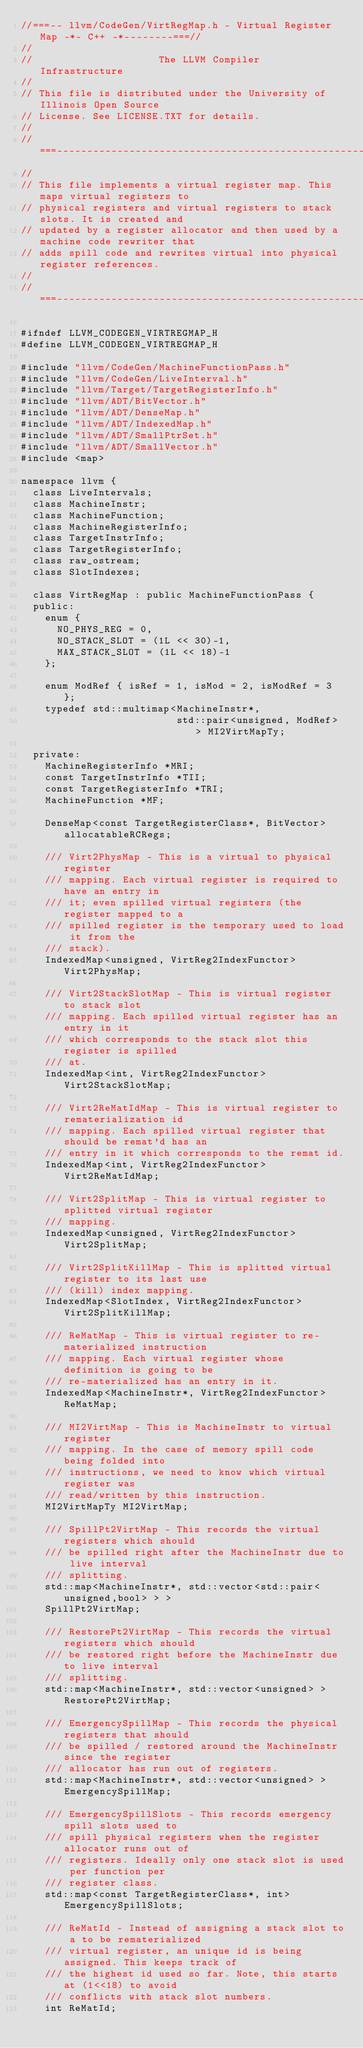<code> <loc_0><loc_0><loc_500><loc_500><_C_>//===-- llvm/CodeGen/VirtRegMap.h - Virtual Register Map -*- C++ -*--------===//
//
//                     The LLVM Compiler Infrastructure
//
// This file is distributed under the University of Illinois Open Source
// License. See LICENSE.TXT for details.
//
//===----------------------------------------------------------------------===//
//
// This file implements a virtual register map. This maps virtual registers to
// physical registers and virtual registers to stack slots. It is created and
// updated by a register allocator and then used by a machine code rewriter that
// adds spill code and rewrites virtual into physical register references.
//
//===----------------------------------------------------------------------===//

#ifndef LLVM_CODEGEN_VIRTREGMAP_H
#define LLVM_CODEGEN_VIRTREGMAP_H

#include "llvm/CodeGen/MachineFunctionPass.h"
#include "llvm/CodeGen/LiveInterval.h"
#include "llvm/Target/TargetRegisterInfo.h"
#include "llvm/ADT/BitVector.h"
#include "llvm/ADT/DenseMap.h"
#include "llvm/ADT/IndexedMap.h"
#include "llvm/ADT/SmallPtrSet.h"
#include "llvm/ADT/SmallVector.h"
#include <map>

namespace llvm {
  class LiveIntervals;
  class MachineInstr;
  class MachineFunction;
  class MachineRegisterInfo;
  class TargetInstrInfo;
  class TargetRegisterInfo;
  class raw_ostream;
  class SlotIndexes;

  class VirtRegMap : public MachineFunctionPass {
  public:
    enum {
      NO_PHYS_REG = 0,
      NO_STACK_SLOT = (1L << 30)-1,
      MAX_STACK_SLOT = (1L << 18)-1
    };

    enum ModRef { isRef = 1, isMod = 2, isModRef = 3 };
    typedef std::multimap<MachineInstr*,
                          std::pair<unsigned, ModRef> > MI2VirtMapTy;

  private:
    MachineRegisterInfo *MRI;
    const TargetInstrInfo *TII;
    const TargetRegisterInfo *TRI;
    MachineFunction *MF;

    DenseMap<const TargetRegisterClass*, BitVector> allocatableRCRegs;

    /// Virt2PhysMap - This is a virtual to physical register
    /// mapping. Each virtual register is required to have an entry in
    /// it; even spilled virtual registers (the register mapped to a
    /// spilled register is the temporary used to load it from the
    /// stack).
    IndexedMap<unsigned, VirtReg2IndexFunctor> Virt2PhysMap;

    /// Virt2StackSlotMap - This is virtual register to stack slot
    /// mapping. Each spilled virtual register has an entry in it
    /// which corresponds to the stack slot this register is spilled
    /// at.
    IndexedMap<int, VirtReg2IndexFunctor> Virt2StackSlotMap;

    /// Virt2ReMatIdMap - This is virtual register to rematerialization id
    /// mapping. Each spilled virtual register that should be remat'd has an
    /// entry in it which corresponds to the remat id.
    IndexedMap<int, VirtReg2IndexFunctor> Virt2ReMatIdMap;

    /// Virt2SplitMap - This is virtual register to splitted virtual register
    /// mapping.
    IndexedMap<unsigned, VirtReg2IndexFunctor> Virt2SplitMap;

    /// Virt2SplitKillMap - This is splitted virtual register to its last use
    /// (kill) index mapping.
    IndexedMap<SlotIndex, VirtReg2IndexFunctor> Virt2SplitKillMap;

    /// ReMatMap - This is virtual register to re-materialized instruction
    /// mapping. Each virtual register whose definition is going to be
    /// re-materialized has an entry in it.
    IndexedMap<MachineInstr*, VirtReg2IndexFunctor> ReMatMap;

    /// MI2VirtMap - This is MachineInstr to virtual register
    /// mapping. In the case of memory spill code being folded into
    /// instructions, we need to know which virtual register was
    /// read/written by this instruction.
    MI2VirtMapTy MI2VirtMap;

    /// SpillPt2VirtMap - This records the virtual registers which should
    /// be spilled right after the MachineInstr due to live interval
    /// splitting.
    std::map<MachineInstr*, std::vector<std::pair<unsigned,bool> > >
    SpillPt2VirtMap;

    /// RestorePt2VirtMap - This records the virtual registers which should
    /// be restored right before the MachineInstr due to live interval
    /// splitting.
    std::map<MachineInstr*, std::vector<unsigned> > RestorePt2VirtMap;

    /// EmergencySpillMap - This records the physical registers that should
    /// be spilled / restored around the MachineInstr since the register
    /// allocator has run out of registers.
    std::map<MachineInstr*, std::vector<unsigned> > EmergencySpillMap;

    /// EmergencySpillSlots - This records emergency spill slots used to
    /// spill physical registers when the register allocator runs out of
    /// registers. Ideally only one stack slot is used per function per
    /// register class.
    std::map<const TargetRegisterClass*, int> EmergencySpillSlots;

    /// ReMatId - Instead of assigning a stack slot to a to be rematerialized
    /// virtual register, an unique id is being assigned. This keeps track of
    /// the highest id used so far. Note, this starts at (1<<18) to avoid
    /// conflicts with stack slot numbers.
    int ReMatId;
</code> 